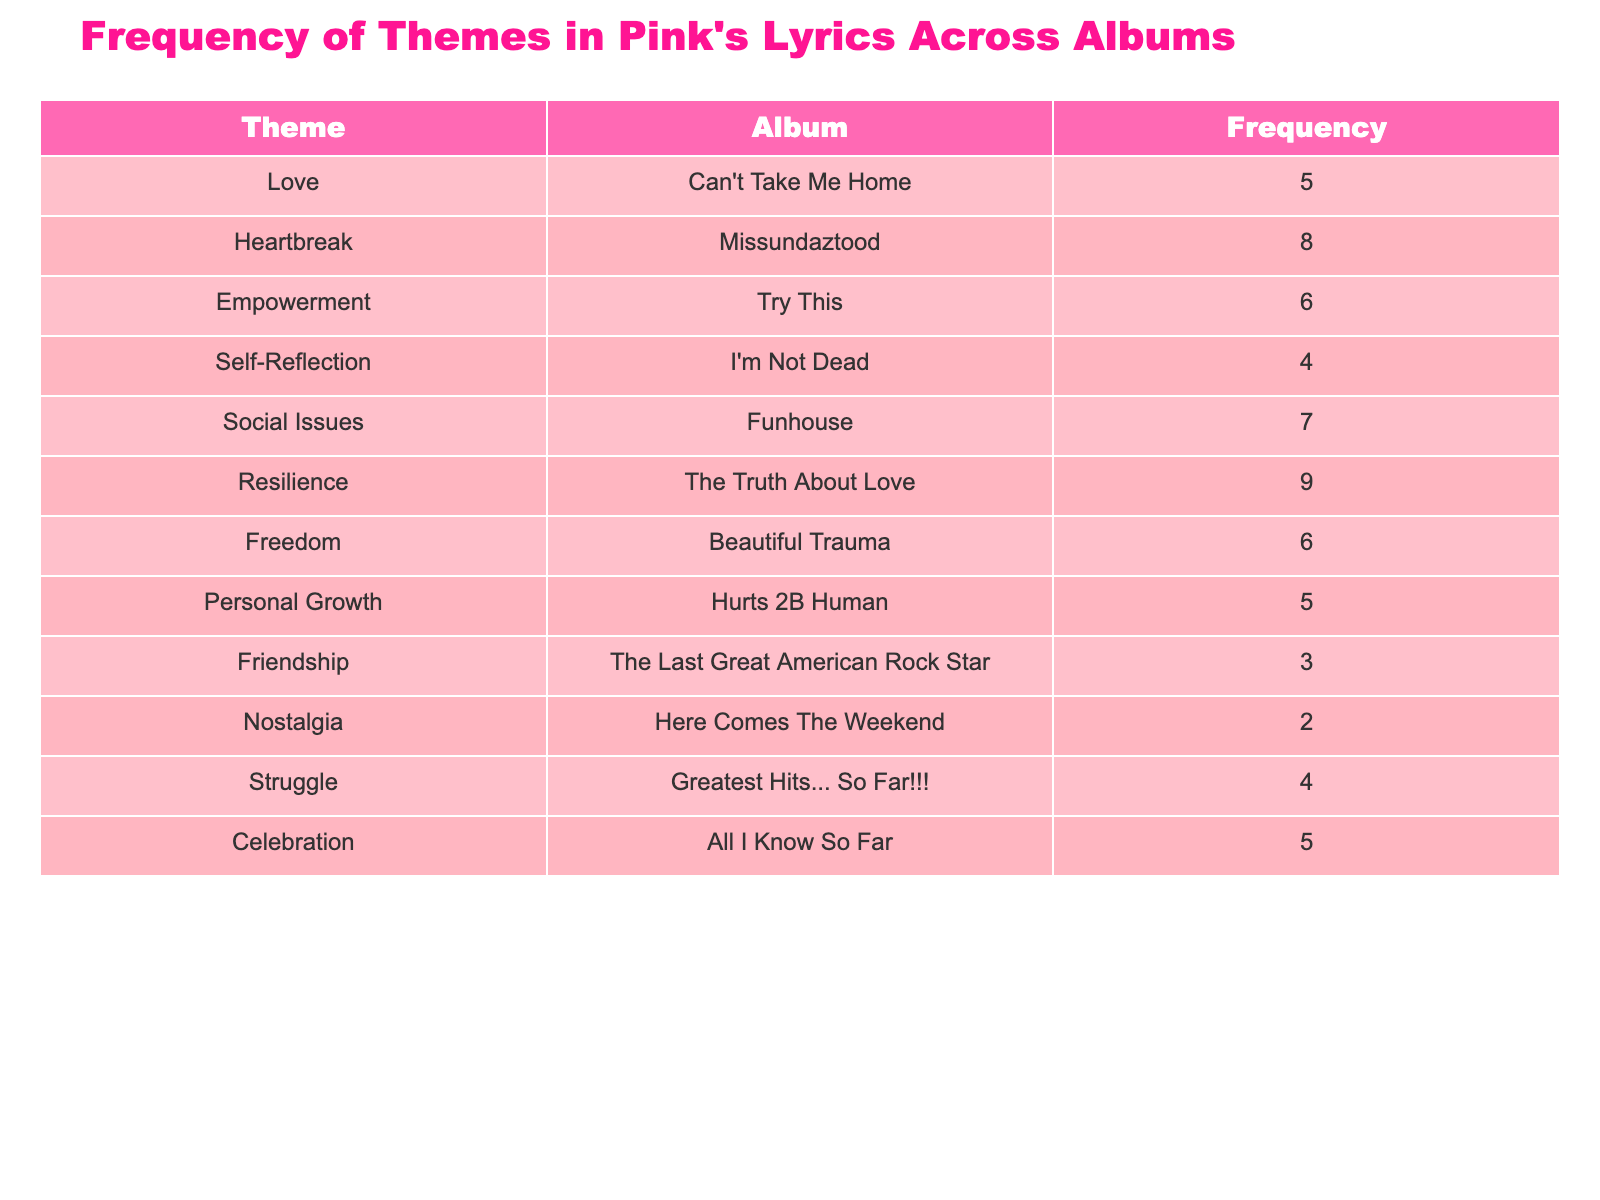What is the theme with the highest frequency in Pink's lyrics? By examining the frequency values in the table, the theme with the highest frequency is "Resilience" from the album "The Truth About Love," which has a frequency of 9.
Answer: Resilience How many themes are represented in the table? By counting the number of rows in the table, there are 12 distinct themes listed.
Answer: 12 Which album features the theme of "Heartbreak" and what is its frequency? According to the table, the theme "Heartbreak" is featured in the album "Missundaztood" with a frequency of 8.
Answer: Missundaztood, 8 What is the total frequency of all themes related to empowerment across Pink's albums? The themes related to empowerment based on the table are "Empowerment" (6) and "Resilience" (9). Adding them gives a total frequency of 6 + 9 = 15.
Answer: 15 Are there any themes in Pink's lyrics that have a frequency of 3? Yes, there is a theme listed with a frequency of 3, which is "Friendship" from the album "The Last Great American Rock Star."
Answer: Yes What is the difference in frequency between the themes "Love" and "Struggle"? The frequency for "Love" is 5 and for "Struggle" is 4. The difference is 5 - 4 = 1.
Answer: 1 Which theme appears most frequently in the album "Beautiful Trauma"? From the table, the theme "Freedom" appears in the album "Beautiful Trauma" with a frequency of 6, which is the only theme listed for that album.
Answer: Freedom, 6 How many themes related to personal connection (like Love, Friendship, and Heartbreak) have a frequency greater than 5? The themes related to personal connection with frequencies greater than 5 are "Heartbreak" (8) and "Love" (5), but since "Love" does not exceed 5, we only count "Heartbreak," giving a total of 1 theme.
Answer: 1 What is the average frequency of themes across all albums? To find the average, first sum the frequencies: 5 + 8 + 6 + 4 + 7 + 9 + 6 + 5 + 3 + 2 + 4 + 5 = 60. Since there are 12 themes, the average is 60/12 = 5.
Answer: 5 